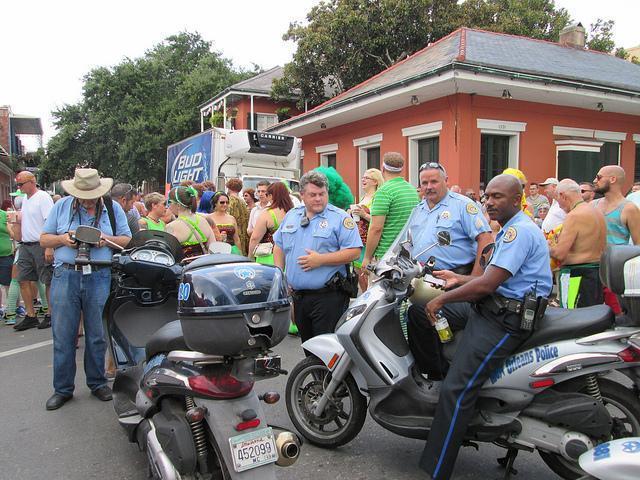How many policeman are pictured?
Give a very brief answer. 3. How many people can you see?
Give a very brief answer. 11. How many motorcycles can you see?
Give a very brief answer. 2. 